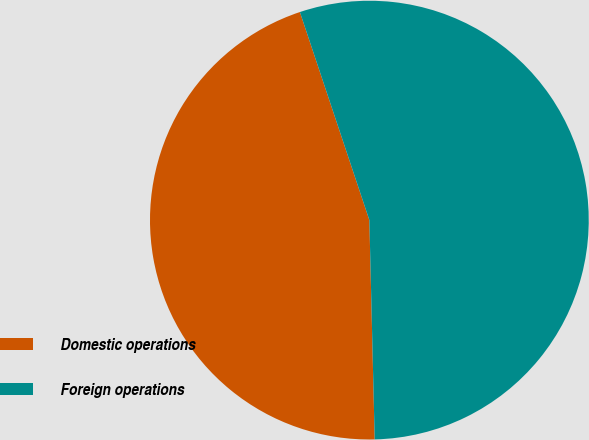Convert chart. <chart><loc_0><loc_0><loc_500><loc_500><pie_chart><fcel>Domestic operations<fcel>Foreign operations<nl><fcel>45.26%<fcel>54.74%<nl></chart> 